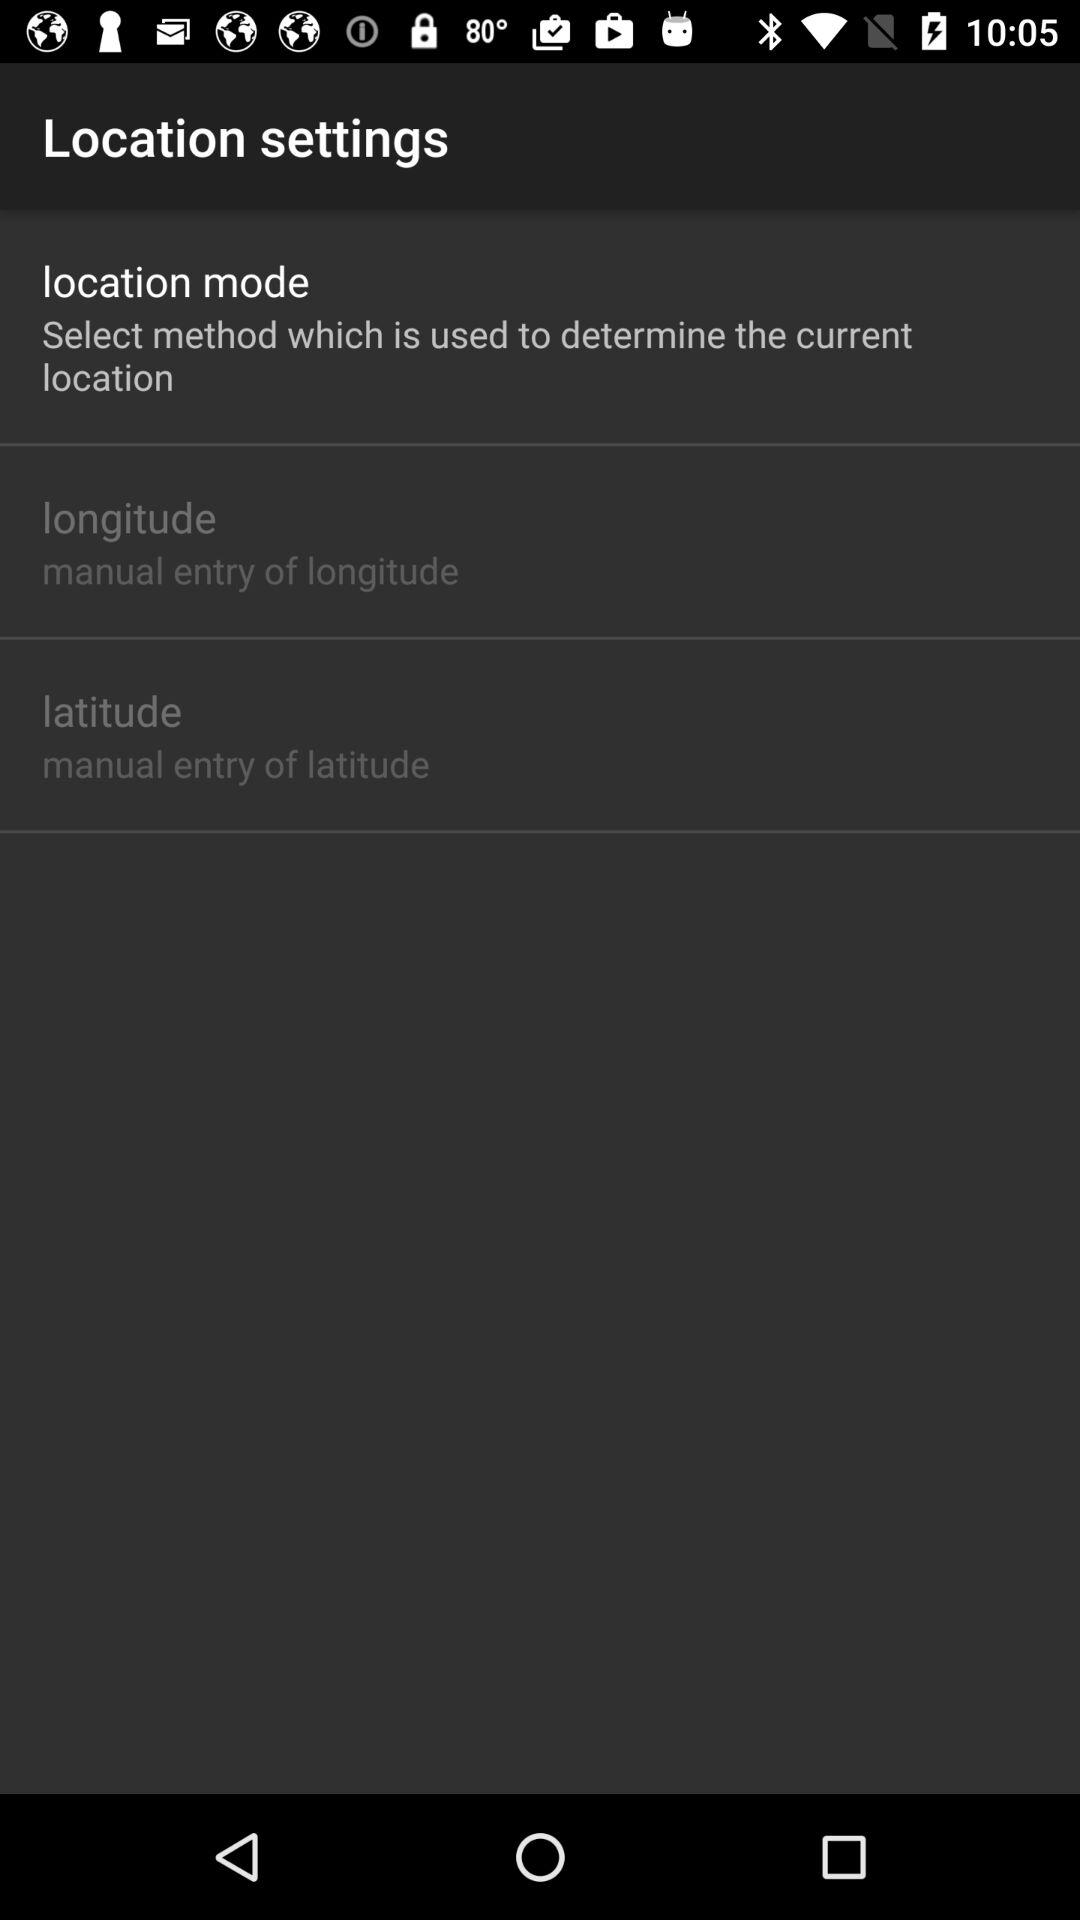How do I enter the latitude? You can manually enter the latitude. 